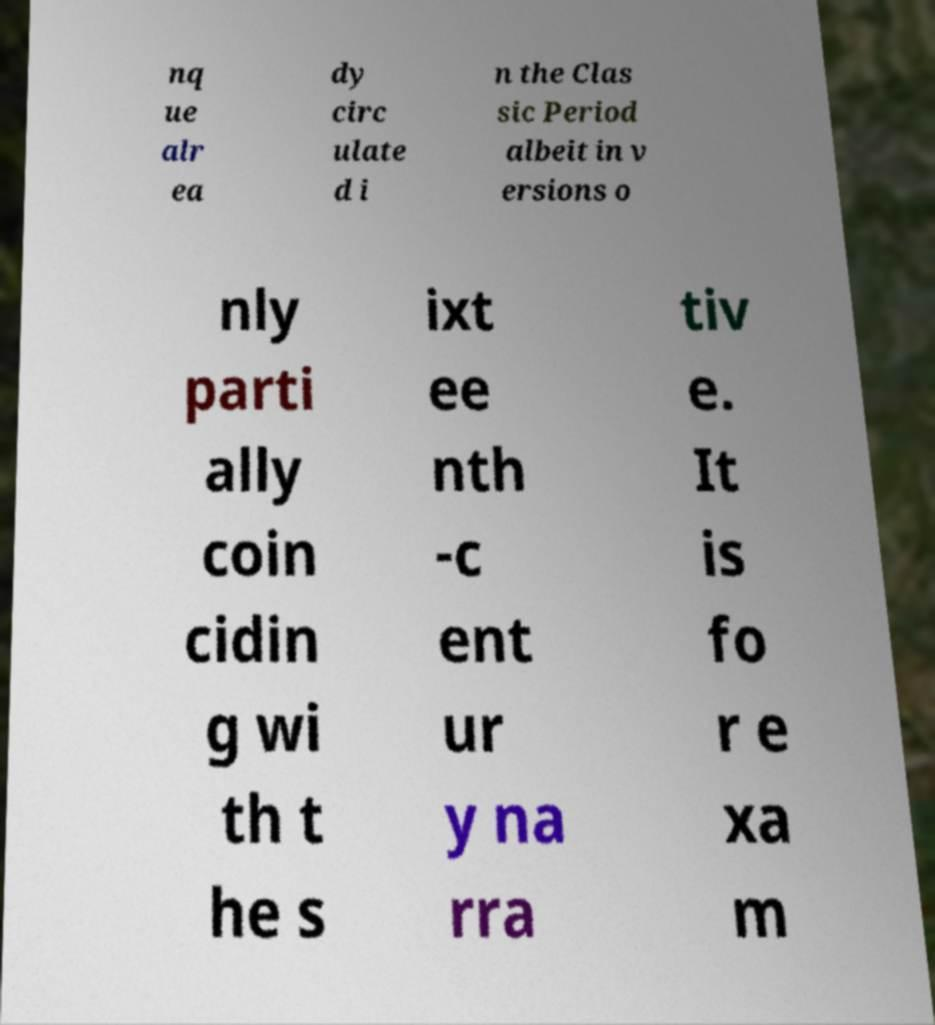What messages or text are displayed in this image? I need them in a readable, typed format. nq ue alr ea dy circ ulate d i n the Clas sic Period albeit in v ersions o nly parti ally coin cidin g wi th t he s ixt ee nth -c ent ur y na rra tiv e. It is fo r e xa m 